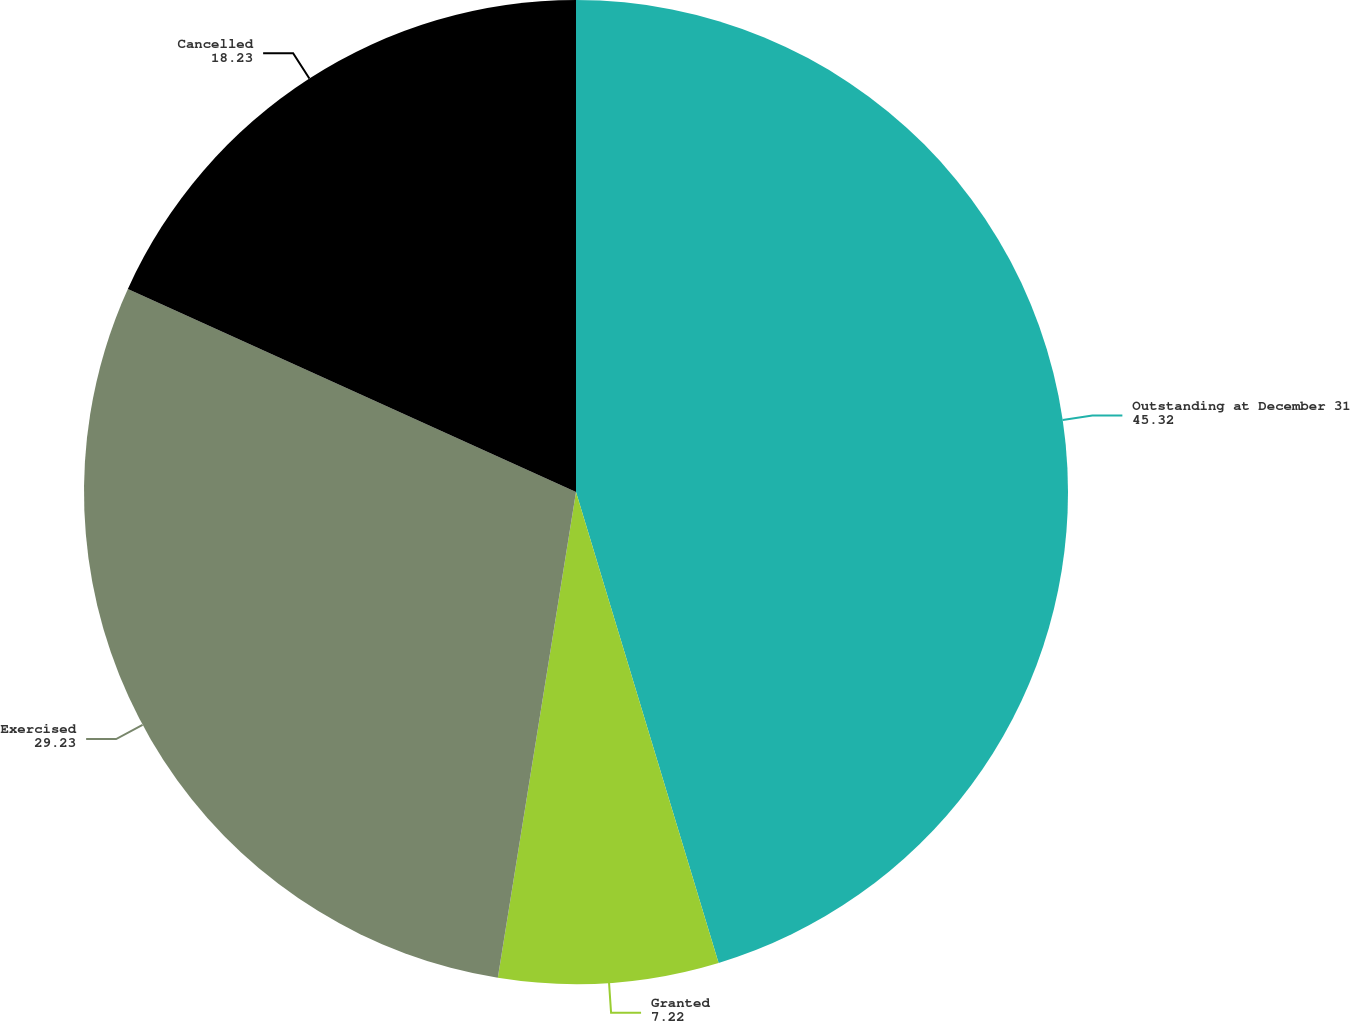<chart> <loc_0><loc_0><loc_500><loc_500><pie_chart><fcel>Outstanding at December 31<fcel>Granted<fcel>Exercised<fcel>Cancelled<nl><fcel>45.32%<fcel>7.22%<fcel>29.23%<fcel>18.23%<nl></chart> 